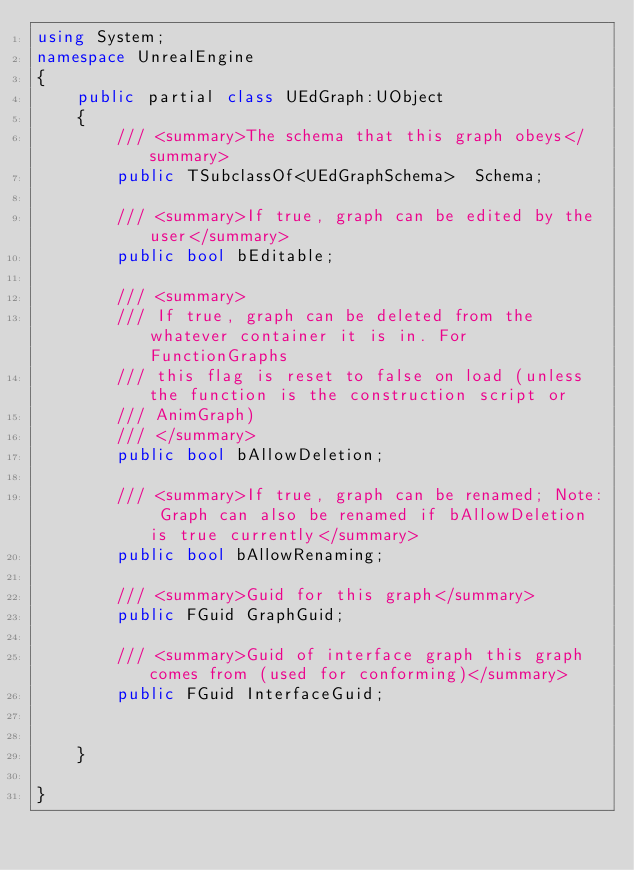Convert code to text. <code><loc_0><loc_0><loc_500><loc_500><_C#_>using System;
namespace UnrealEngine
{
	public partial class UEdGraph:UObject
	{
		/// <summary>The schema that this graph obeys</summary>
		public TSubclassOf<UEdGraphSchema>  Schema;
		
		/// <summary>If true, graph can be edited by the user</summary>
		public bool bEditable;
		
		/// <summary>
		/// If true, graph can be deleted from the whatever container it is in. For FunctionGraphs
		/// this flag is reset to false on load (unless the function is the construction script or
		/// AnimGraph)
		/// </summary>
		public bool bAllowDeletion;
		
		/// <summary>If true, graph can be renamed; Note: Graph can also be renamed if bAllowDeletion is true currently</summary>
		public bool bAllowRenaming;
		
		/// <summary>Guid for this graph</summary>
		public FGuid GraphGuid;
		
		/// <summary>Guid of interface graph this graph comes from (used for conforming)</summary>
		public FGuid InterfaceGuid;
		
		
	}
	
}
</code> 